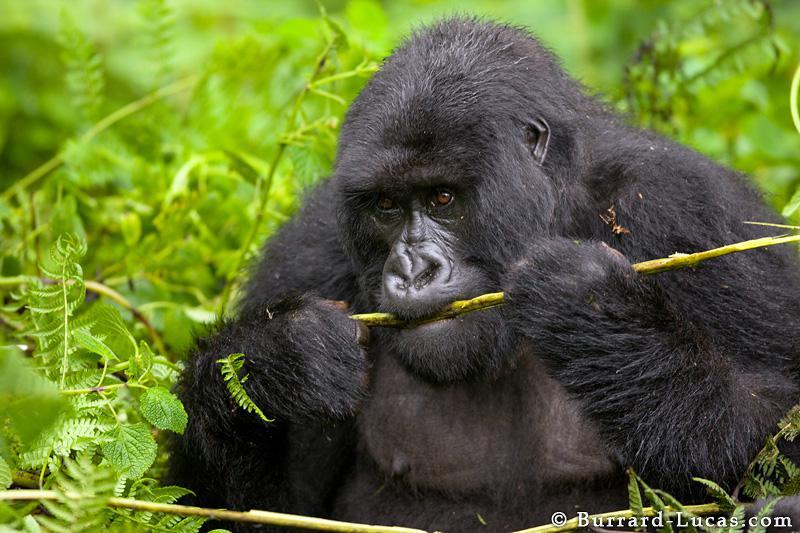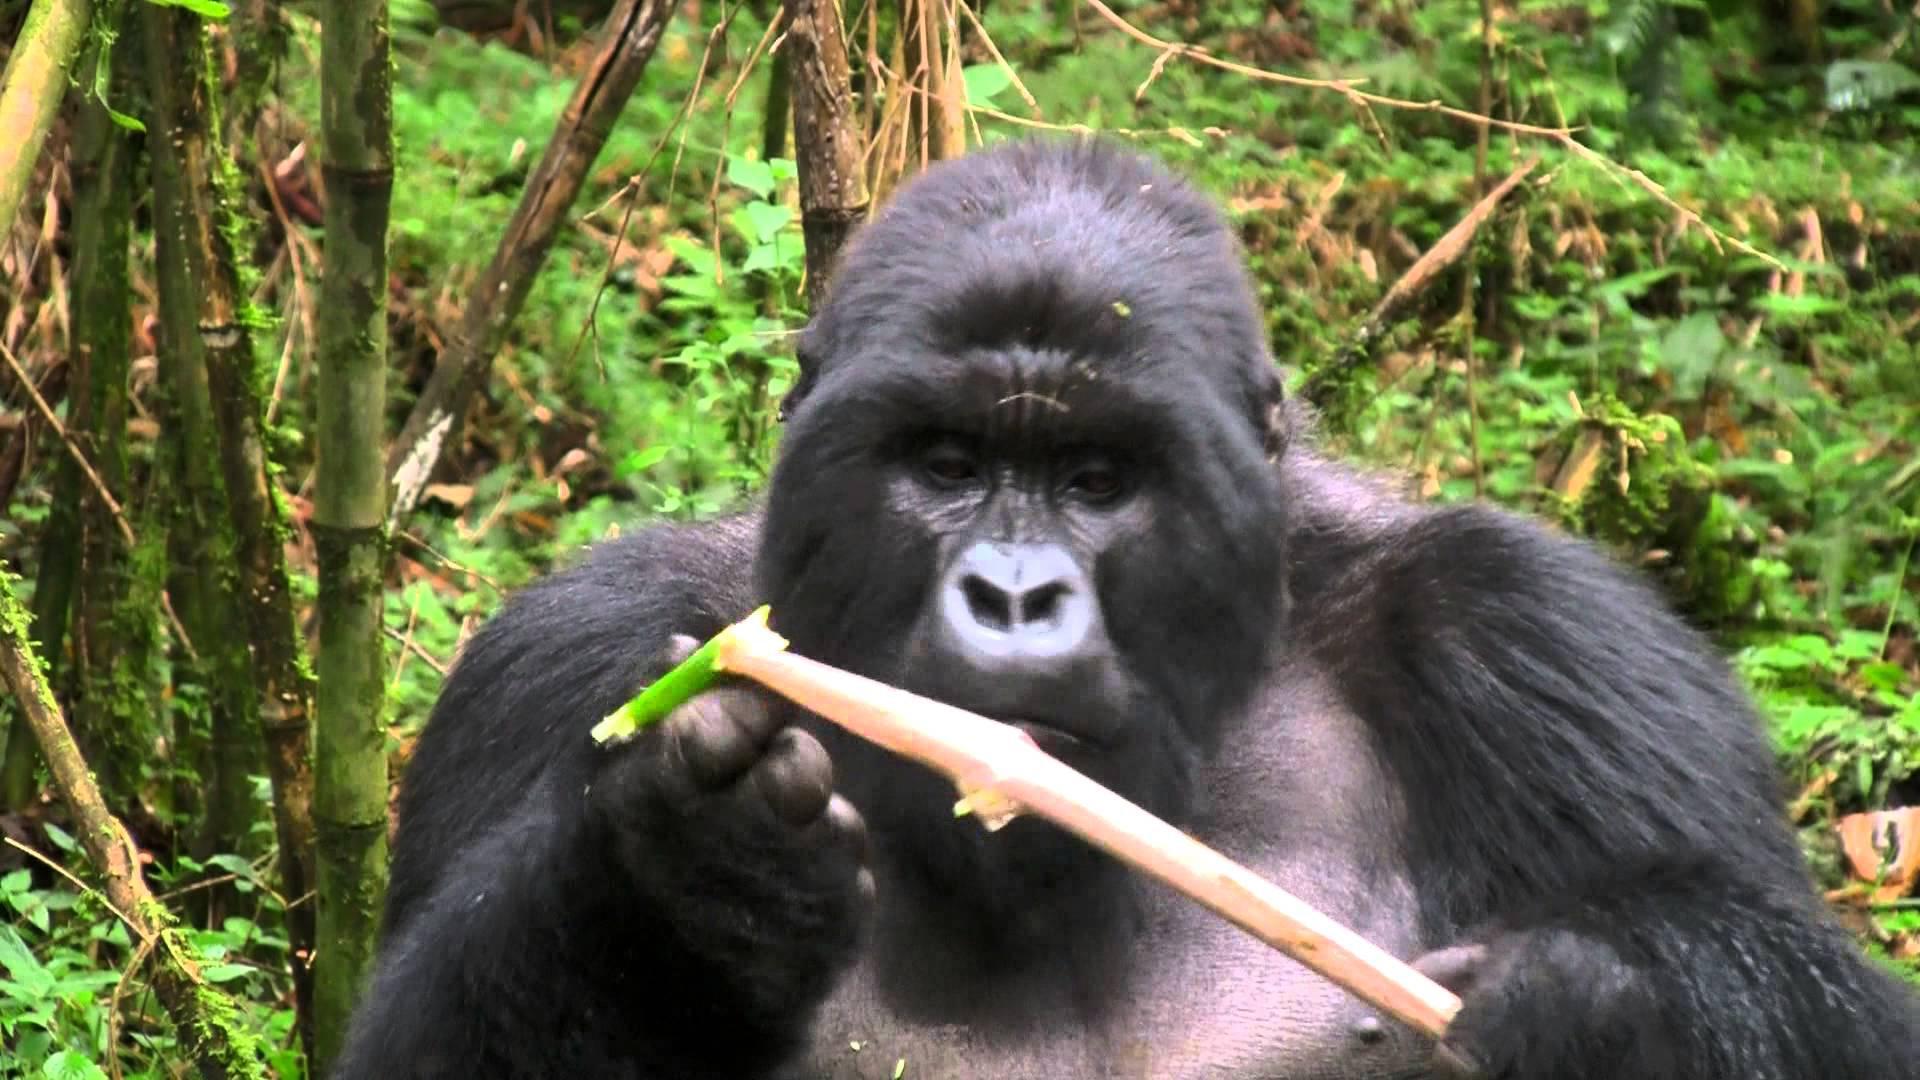The first image is the image on the left, the second image is the image on the right. Evaluate the accuracy of this statement regarding the images: "In each image there is a single gorilla and it is eating.". Is it true? Answer yes or no. Yes. The first image is the image on the left, the second image is the image on the right. Evaluate the accuracy of this statement regarding the images: "One image shows a gorilla holding some type of stalk by its face, and the other image features an adult gorilla moving toward the camera.". Is it true? Answer yes or no. No. 